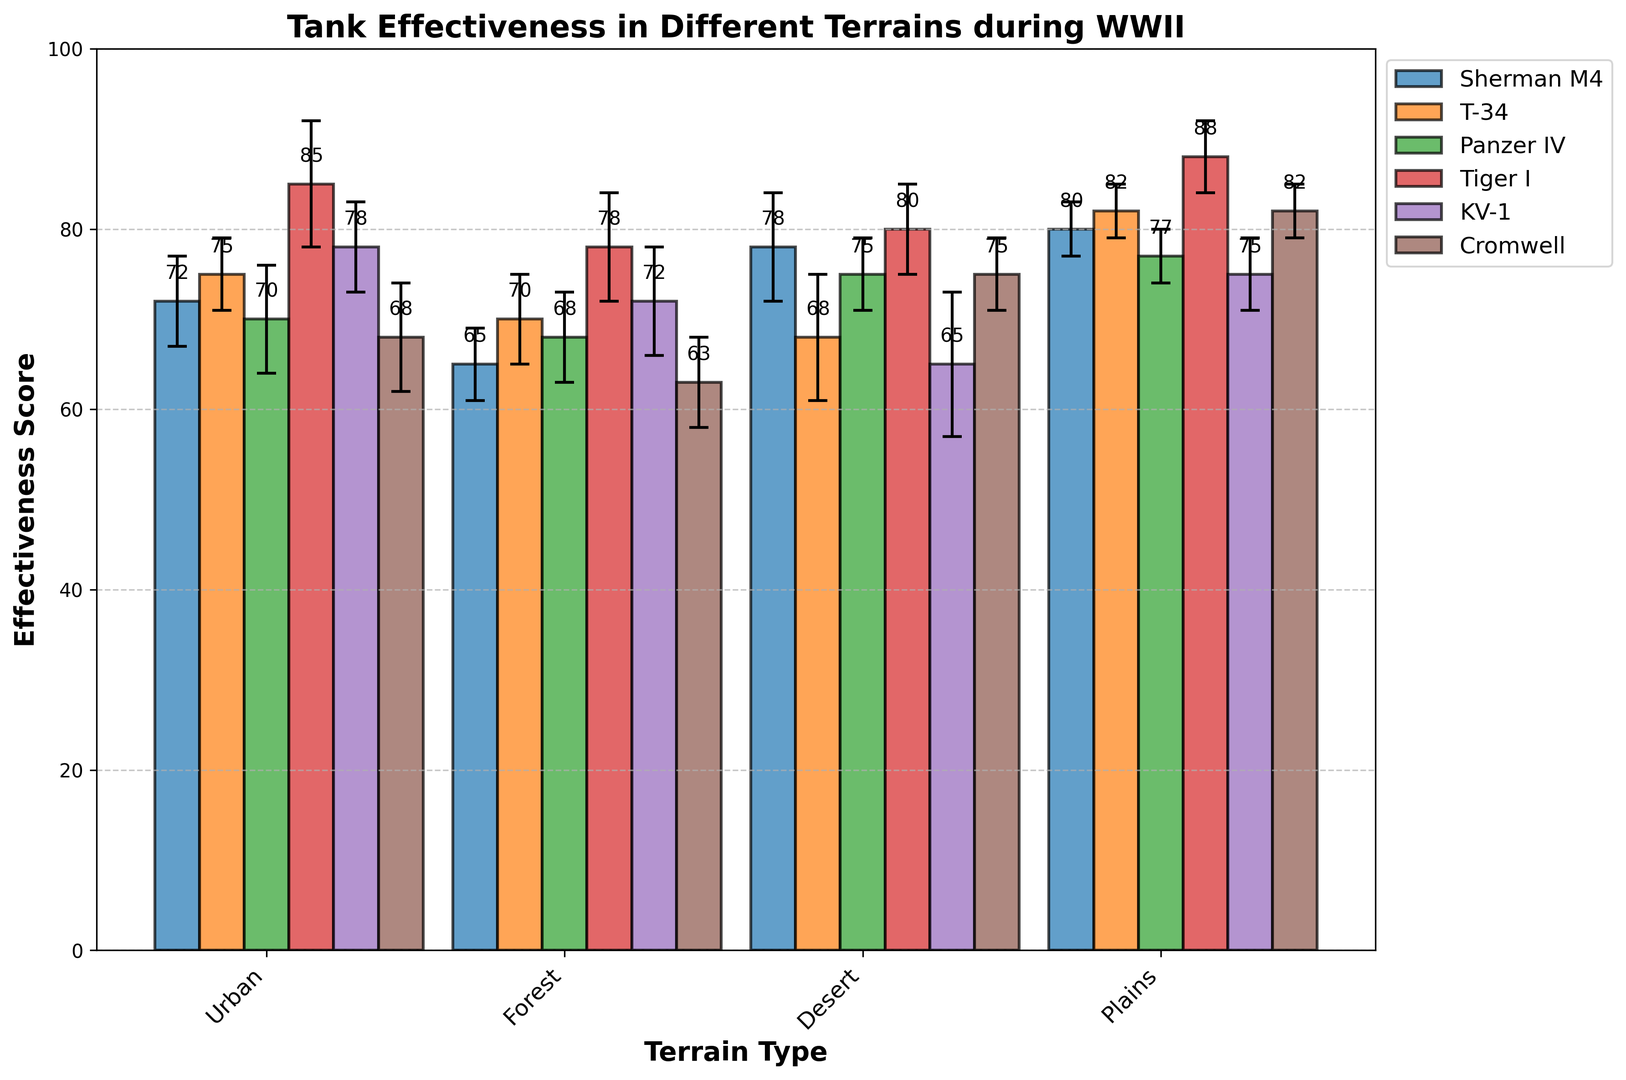How does the effectiveness of the Sherman M4 compare to the T-34 in Desert terrain? To compare the effectiveness scores, look at the Sherman M4 bar and the T-34 bar in the Desert terrain section. Sherman M4 has an effectiveness score of 78, while T-34 has a score of 68. Thus, the Sherman M4 is more effective in Desert terrain compared to the T-34.
Answer: Sherman M4 is more effective What is the average effectiveness of the Tiger I across all terrains? Calculate the average by summing the effectiveness scores of Tiger I across all terrains and then dividing by the number of terrains: (85 + 78 + 80 + 88) / 4 = 331 / 4 = 82.75.
Answer: 82.75 Which tank model has the lowest effectiveness score in Forest terrain? Check the bars representing effectiveness scores in the Forest terrain section. The Cromwell has the lowest effectiveness score of 63 in the Forest terrain.
Answer: Cromwell By how much does the effectiveness of the Panzer IV increase from Forest to Desert terrain? To find the increase, subtract the effectiveness score of Panzer IV in Forest from its score in Desert: 75 - 68 = 7.
Answer: 7 Which terrain type shows the highest effectiveness score for the KV-1 tank? Compare the heights of the bars representing the effectiveness of the KV-1 in different terrains. The highest bar for KV-1 appears in Urban terrain with a score of 78.
Answer: Urban What is the difference in effectiveness between the Cromwell and Sherman M4 tanks in Plains terrain? Check the effectiveness scores of Cromwell and Sherman M4 in the Plains terrain. The Cromwell has a score of 82 and the Sherman M4 has a score of 80. The difference is 82 - 80 = 2.
Answer: 2 Rank the tanks based on their effectiveness in Urban terrain from highest to lowest. Compare the effectiveness scores of all tanks in Urban terrain: Tiger I (85), KV-1 (78), T-34 (75), Sherman M4 (72), Panzer IV (70), Cromwell (68). The ranking from highest to lowest is: Tiger I > KV-1 > T-34 > Sherman M4 > Panzer IV > Cromwell.
Answer: Tiger I > KV-1 > T-34 > Sherman M4 > Panzer IV > Cromwell By how much does the effective score of T-34 in Forest terrain deviate from its effectiveness in Plains terrain? Calculate the difference in effectiveness scores for T-34 between Forest and Plains: 82 - 70 = 12.
Answer: 12 Which tank model exhibits the highest variability in effectiveness across different terrains? Determine variability by assessing the error margins. The KV-1 shows one of the highest variability with error margins of (5, 6, 8, 4).
Answer: KV-1 Among all tanks in Desert terrain, which one has the highest effectiveness score, and what is the score? Compare the desert effectiveness scores of all tanks. The highest score is for Tiger I with a score of 80.
Answer: Tiger I, 80 